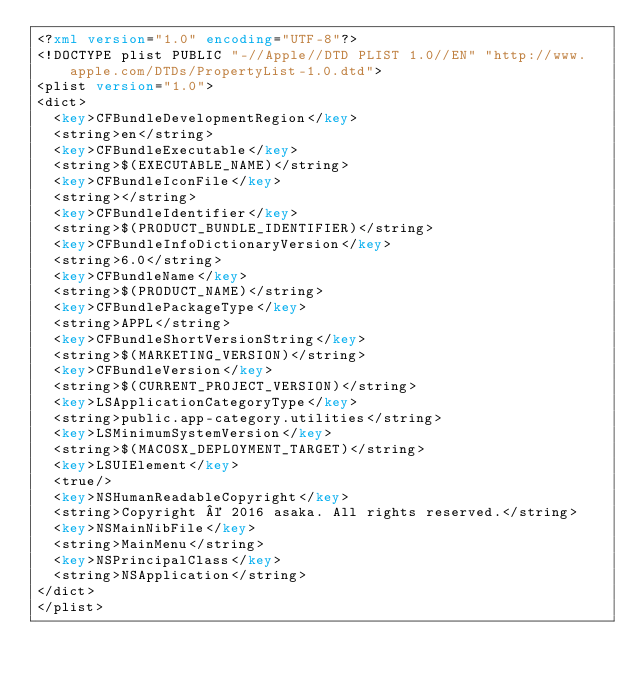Convert code to text. <code><loc_0><loc_0><loc_500><loc_500><_XML_><?xml version="1.0" encoding="UTF-8"?>
<!DOCTYPE plist PUBLIC "-//Apple//DTD PLIST 1.0//EN" "http://www.apple.com/DTDs/PropertyList-1.0.dtd">
<plist version="1.0">
<dict>
	<key>CFBundleDevelopmentRegion</key>
	<string>en</string>
	<key>CFBundleExecutable</key>
	<string>$(EXECUTABLE_NAME)</string>
	<key>CFBundleIconFile</key>
	<string></string>
	<key>CFBundleIdentifier</key>
	<string>$(PRODUCT_BUNDLE_IDENTIFIER)</string>
	<key>CFBundleInfoDictionaryVersion</key>
	<string>6.0</string>
	<key>CFBundleName</key>
	<string>$(PRODUCT_NAME)</string>
	<key>CFBundlePackageType</key>
	<string>APPL</string>
	<key>CFBundleShortVersionString</key>
	<string>$(MARKETING_VERSION)</string>
	<key>CFBundleVersion</key>
	<string>$(CURRENT_PROJECT_VERSION)</string>
	<key>LSApplicationCategoryType</key>
	<string>public.app-category.utilities</string>
	<key>LSMinimumSystemVersion</key>
	<string>$(MACOSX_DEPLOYMENT_TARGET)</string>
	<key>LSUIElement</key>
	<true/>
	<key>NSHumanReadableCopyright</key>
	<string>Copyright © 2016 asaka. All rights reserved.</string>
	<key>NSMainNibFile</key>
	<string>MainMenu</string>
	<key>NSPrincipalClass</key>
	<string>NSApplication</string>
</dict>
</plist>
</code> 